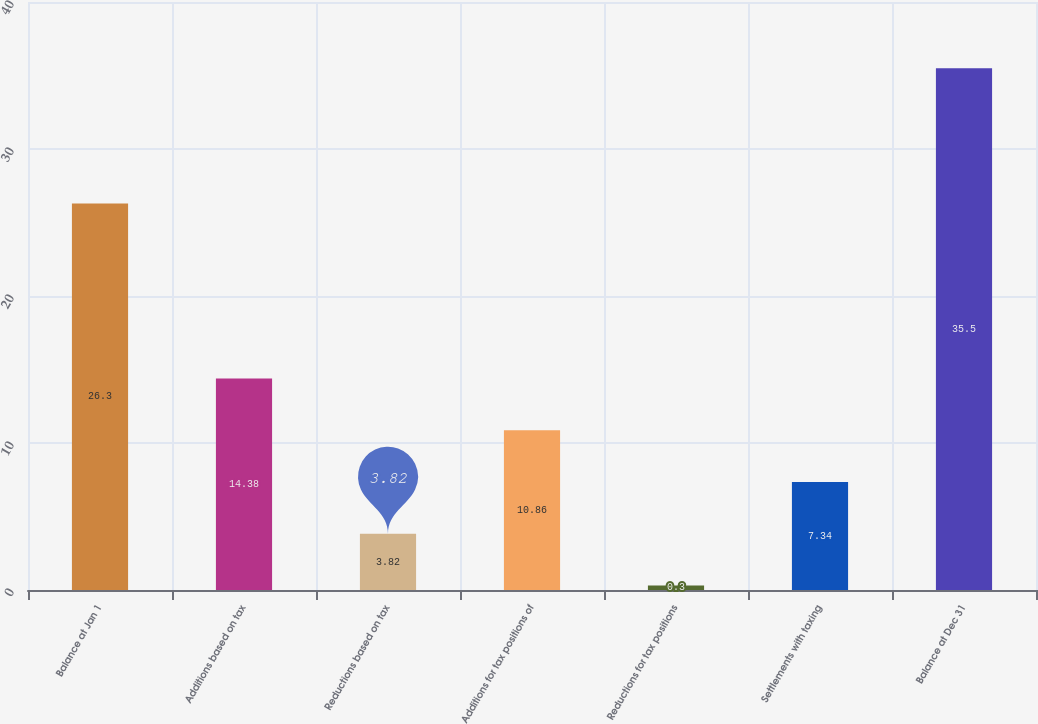Convert chart. <chart><loc_0><loc_0><loc_500><loc_500><bar_chart><fcel>Balance at Jan 1<fcel>Additions based on tax<fcel>Reductions based on tax<fcel>Additions for tax positions of<fcel>Reductions for tax positions<fcel>Settlements with taxing<fcel>Balance at Dec 31<nl><fcel>26.3<fcel>14.38<fcel>3.82<fcel>10.86<fcel>0.3<fcel>7.34<fcel>35.5<nl></chart> 